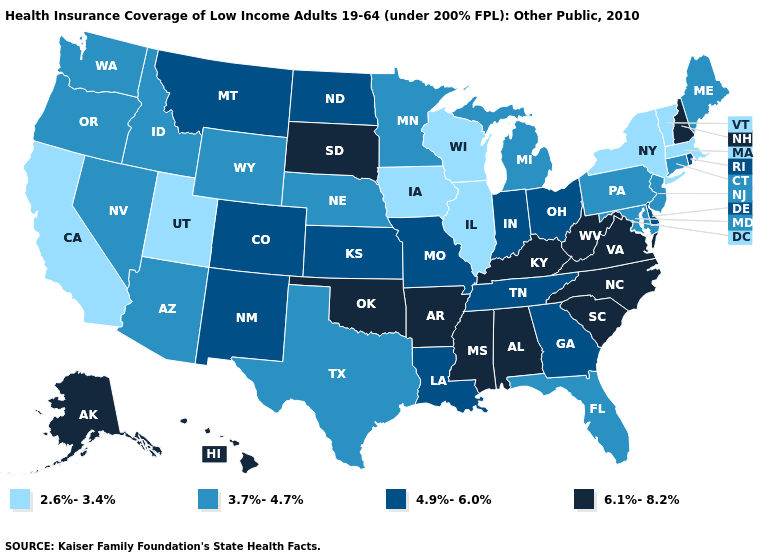Does New Hampshire have the same value as South Dakota?
Write a very short answer. Yes. Among the states that border Vermont , which have the highest value?
Be succinct. New Hampshire. Name the states that have a value in the range 4.9%-6.0%?
Write a very short answer. Colorado, Delaware, Georgia, Indiana, Kansas, Louisiana, Missouri, Montana, New Mexico, North Dakota, Ohio, Rhode Island, Tennessee. What is the lowest value in the West?
Give a very brief answer. 2.6%-3.4%. Name the states that have a value in the range 6.1%-8.2%?
Write a very short answer. Alabama, Alaska, Arkansas, Hawaii, Kentucky, Mississippi, New Hampshire, North Carolina, Oklahoma, South Carolina, South Dakota, Virginia, West Virginia. Name the states that have a value in the range 6.1%-8.2%?
Be succinct. Alabama, Alaska, Arkansas, Hawaii, Kentucky, Mississippi, New Hampshire, North Carolina, Oklahoma, South Carolina, South Dakota, Virginia, West Virginia. What is the value of New Jersey?
Short answer required. 3.7%-4.7%. Does Kansas have the same value as Rhode Island?
Give a very brief answer. Yes. Which states have the lowest value in the MidWest?
Write a very short answer. Illinois, Iowa, Wisconsin. Name the states that have a value in the range 4.9%-6.0%?
Keep it brief. Colorado, Delaware, Georgia, Indiana, Kansas, Louisiana, Missouri, Montana, New Mexico, North Dakota, Ohio, Rhode Island, Tennessee. Name the states that have a value in the range 4.9%-6.0%?
Quick response, please. Colorado, Delaware, Georgia, Indiana, Kansas, Louisiana, Missouri, Montana, New Mexico, North Dakota, Ohio, Rhode Island, Tennessee. Which states have the highest value in the USA?
Quick response, please. Alabama, Alaska, Arkansas, Hawaii, Kentucky, Mississippi, New Hampshire, North Carolina, Oklahoma, South Carolina, South Dakota, Virginia, West Virginia. Name the states that have a value in the range 2.6%-3.4%?
Short answer required. California, Illinois, Iowa, Massachusetts, New York, Utah, Vermont, Wisconsin. Name the states that have a value in the range 3.7%-4.7%?
Quick response, please. Arizona, Connecticut, Florida, Idaho, Maine, Maryland, Michigan, Minnesota, Nebraska, Nevada, New Jersey, Oregon, Pennsylvania, Texas, Washington, Wyoming. Among the states that border Nevada , does Arizona have the highest value?
Concise answer only. Yes. 